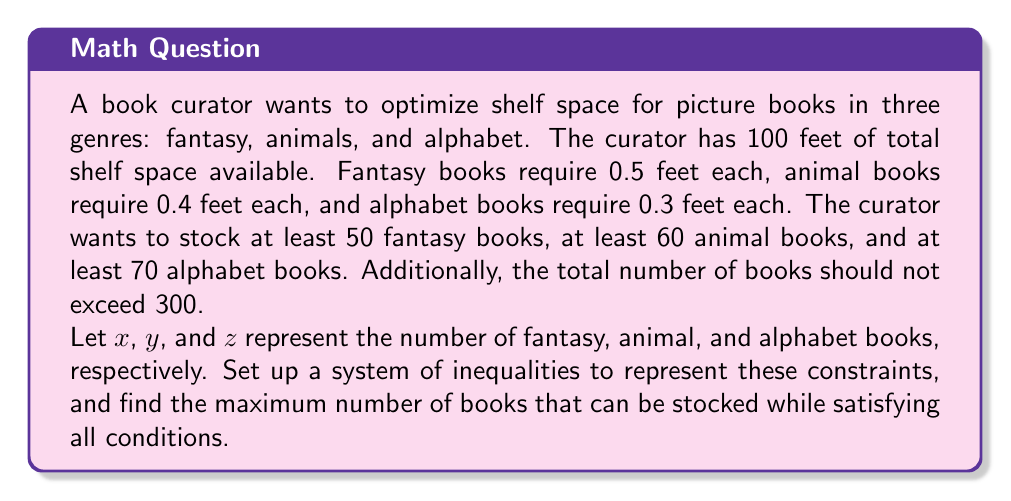Teach me how to tackle this problem. Let's approach this problem step-by-step:

1. Set up the system of inequalities:

   a. Shelf space constraint:
      $$ 0.5x + 0.4y + 0.3z \leq 100 $$

   b. Minimum number of books for each genre:
      $$ x \geq 50 $$
      $$ y \geq 60 $$
      $$ z \geq 70 $$

   c. Total number of books constraint:
      $$ x + y + z \leq 300 $$

   d. Non-negativity constraints:
      $$ x, y, z \geq 0 $$

2. To maximize the total number of books, we need to maximize $x + y + z$.

3. We can use the simplex method or graphical method to solve this linear programming problem. However, we can also use logical reasoning to find the optimal solution:

   a. Start by satisfying the minimum requirements:
      $x = 50$, $y = 60$, $z = 70$

   b. This uses $(50 \times 0.5) + (60 \times 0.4) + (70 \times 0.3) = 25 + 24 + 21 = 70$ feet of shelf space.

   c. We have $100 - 70 = 30$ feet of shelf space remaining.

   d. To maximize the number of books, we should add the smallest books (alphabet books) first:
      $30 \div 0.3 = 100$ additional alphabet books can fit.

   e. This brings our totals to:
      $x = 50$, $y = 60$, $z = 170$

   f. The total number of books is $50 + 60 + 170 = 280$, which satisfies the constraint of not exceeding 300 books.

4. Check if this solution satisfies all constraints:
   - Shelf space: $0.5(50) + 0.4(60) + 0.3(170) = 25 + 24 + 51 = 100$ feet (exactly meets the limit)
   - Minimum books per genre: Satisfied (50 ≥ 50, 60 ≥ 60, 170 ≥ 70)
   - Total books: 280 ≤ 300 (satisfied)

Therefore, the maximum number of books that can be stocked while satisfying all conditions is 280.
Answer: The maximum number of books that can be stocked is 280, with 50 fantasy books, 60 animal books, and 170 alphabet books. 